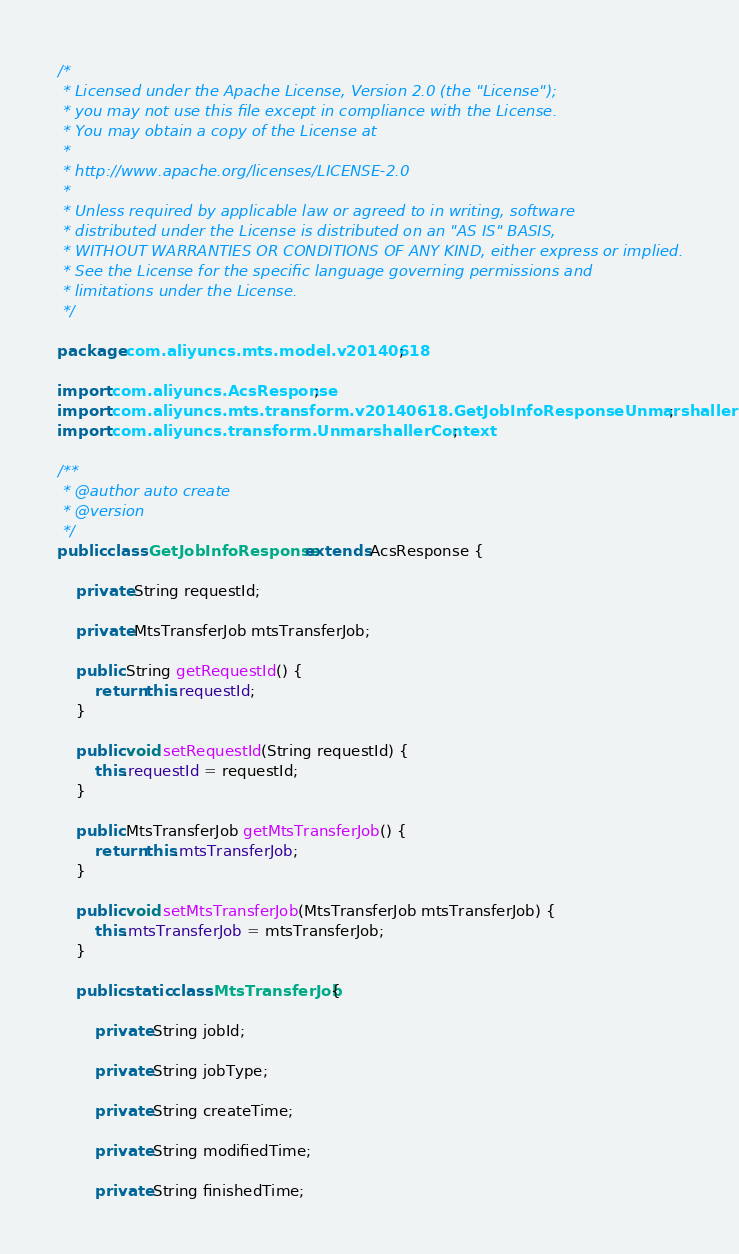<code> <loc_0><loc_0><loc_500><loc_500><_Java_>/*
 * Licensed under the Apache License, Version 2.0 (the "License");
 * you may not use this file except in compliance with the License.
 * You may obtain a copy of the License at
 *
 * http://www.apache.org/licenses/LICENSE-2.0
 *
 * Unless required by applicable law or agreed to in writing, software
 * distributed under the License is distributed on an "AS IS" BASIS,
 * WITHOUT WARRANTIES OR CONDITIONS OF ANY KIND, either express or implied.
 * See the License for the specific language governing permissions and
 * limitations under the License.
 */

package com.aliyuncs.mts.model.v20140618;

import com.aliyuncs.AcsResponse;
import com.aliyuncs.mts.transform.v20140618.GetJobInfoResponseUnmarshaller;
import com.aliyuncs.transform.UnmarshallerContext;

/**
 * @author auto create
 * @version 
 */
public class GetJobInfoResponse extends AcsResponse {

	private String requestId;

	private MtsTransferJob mtsTransferJob;

	public String getRequestId() {
		return this.requestId;
	}

	public void setRequestId(String requestId) {
		this.requestId = requestId;
	}

	public MtsTransferJob getMtsTransferJob() {
		return this.mtsTransferJob;
	}

	public void setMtsTransferJob(MtsTransferJob mtsTransferJob) {
		this.mtsTransferJob = mtsTransferJob;
	}

	public static class MtsTransferJob {

		private String jobId;

		private String jobType;

		private String createTime;

		private String modifiedTime;

		private String finishedTime;
</code> 